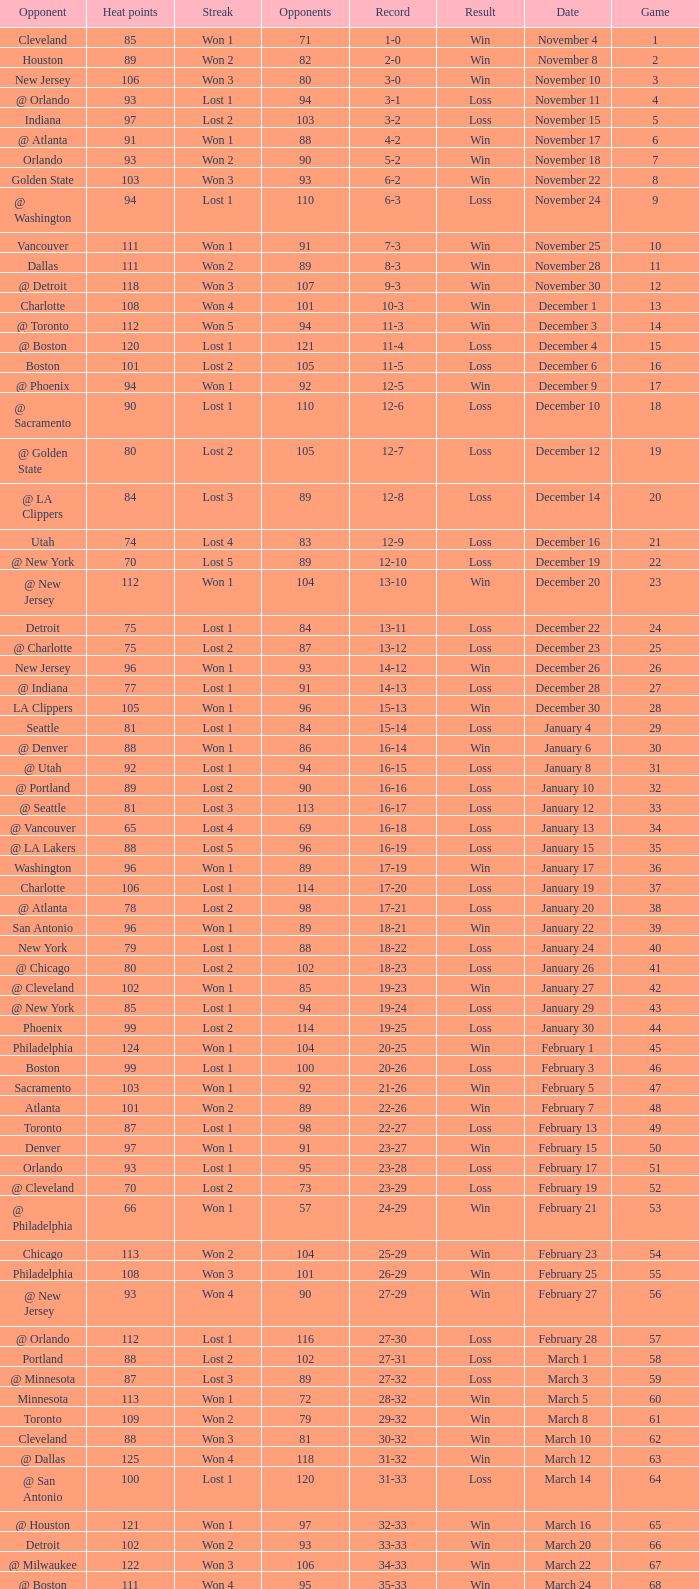What is the highest Game, when Opponents is less than 80, and when Record is "1-0"? 1.0. 